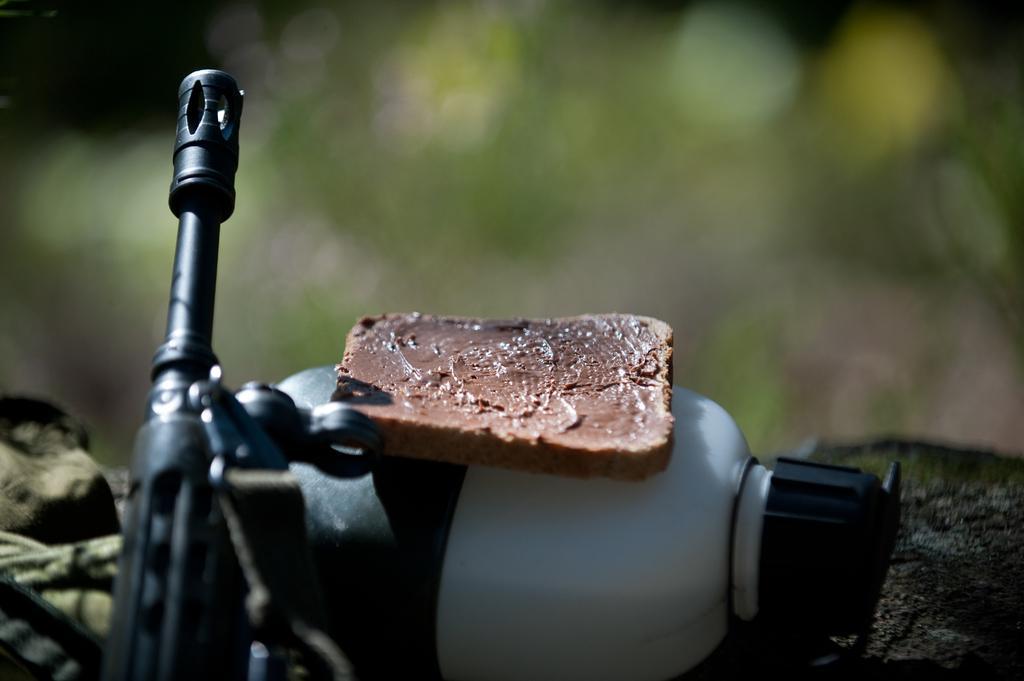In one or two sentences, can you explain what this image depicts? In this picture we can see bread on a bottle and objects. In the background of the image it is blurry. 